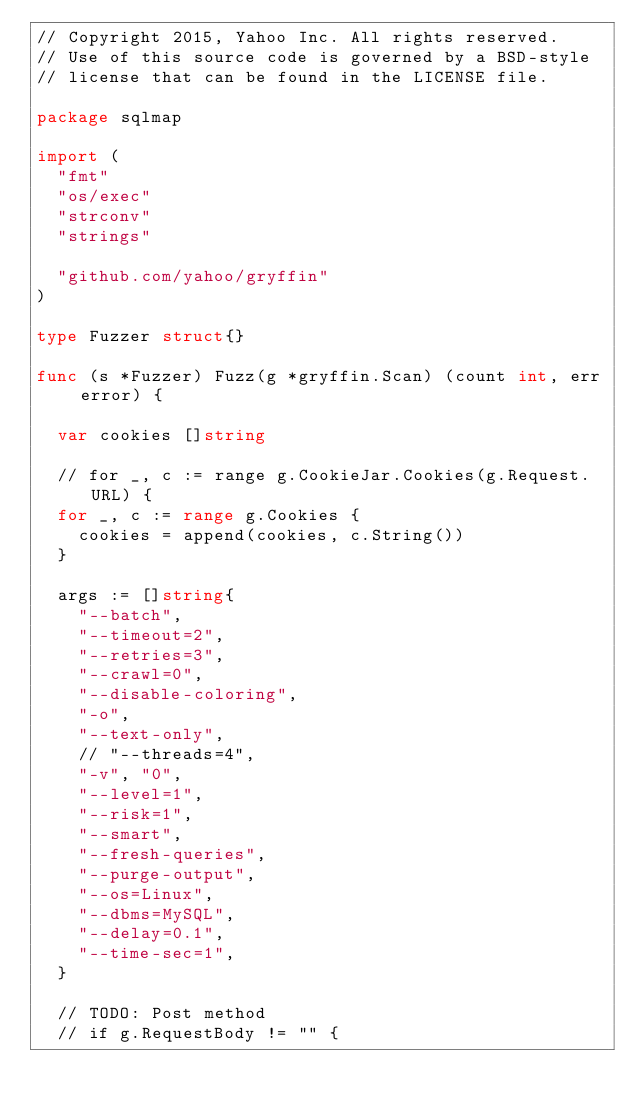Convert code to text. <code><loc_0><loc_0><loc_500><loc_500><_Go_>// Copyright 2015, Yahoo Inc. All rights reserved.
// Use of this source code is governed by a BSD-style
// license that can be found in the LICENSE file.

package sqlmap

import (
	"fmt"
	"os/exec"
	"strconv"
	"strings"

	"github.com/yahoo/gryffin"
)

type Fuzzer struct{}

func (s *Fuzzer) Fuzz(g *gryffin.Scan) (count int, err error) {

	var cookies []string

	// for _, c := range g.CookieJar.Cookies(g.Request.URL) {
	for _, c := range g.Cookies {
		cookies = append(cookies, c.String())
	}

	args := []string{
		"--batch",
		"--timeout=2",
		"--retries=3",
		"--crawl=0",
		"--disable-coloring",
		"-o",
		"--text-only",
		// "--threads=4",
		"-v", "0",
		"--level=1",
		"--risk=1",
		"--smart",
		"--fresh-queries",
		"--purge-output",
		"--os=Linux",
		"--dbms=MySQL",
		"--delay=0.1",
		"--time-sec=1",
	}

	// TODO: Post method
	// if g.RequestBody != "" {</code> 